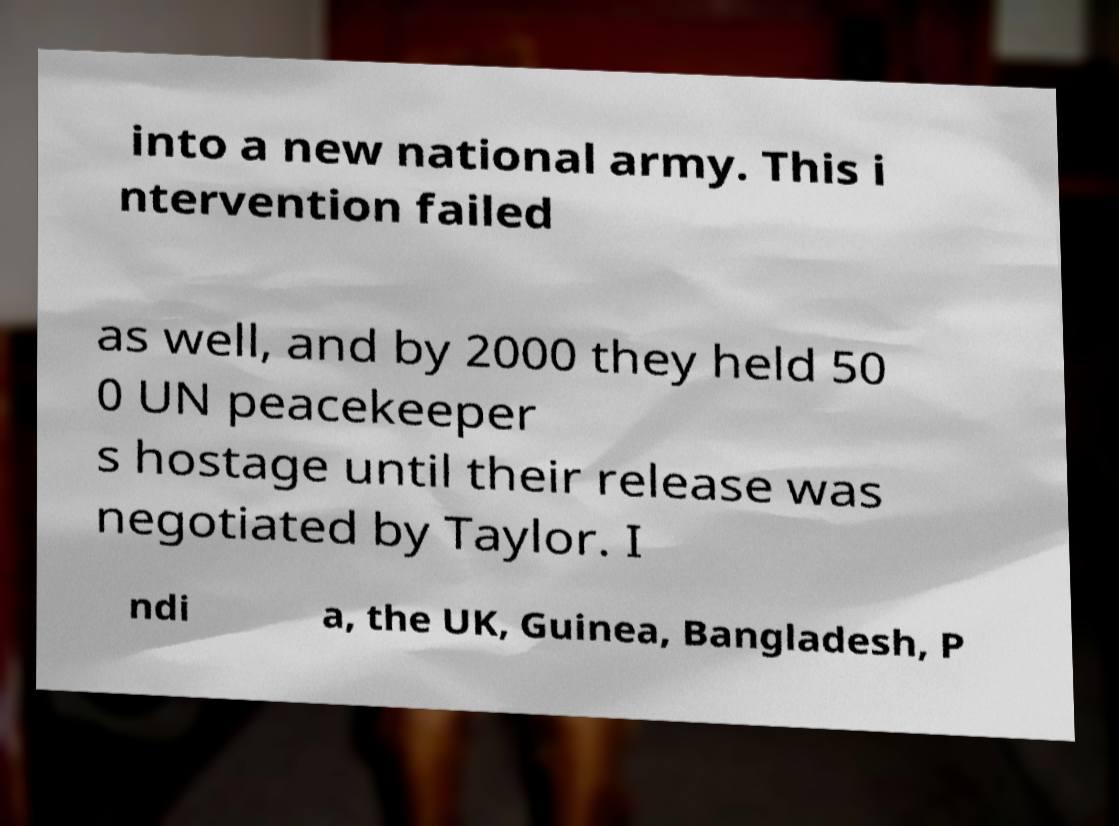Could you assist in decoding the text presented in this image and type it out clearly? into a new national army. This i ntervention failed as well, and by 2000 they held 50 0 UN peacekeeper s hostage until their release was negotiated by Taylor. I ndi a, the UK, Guinea, Bangladesh, P 